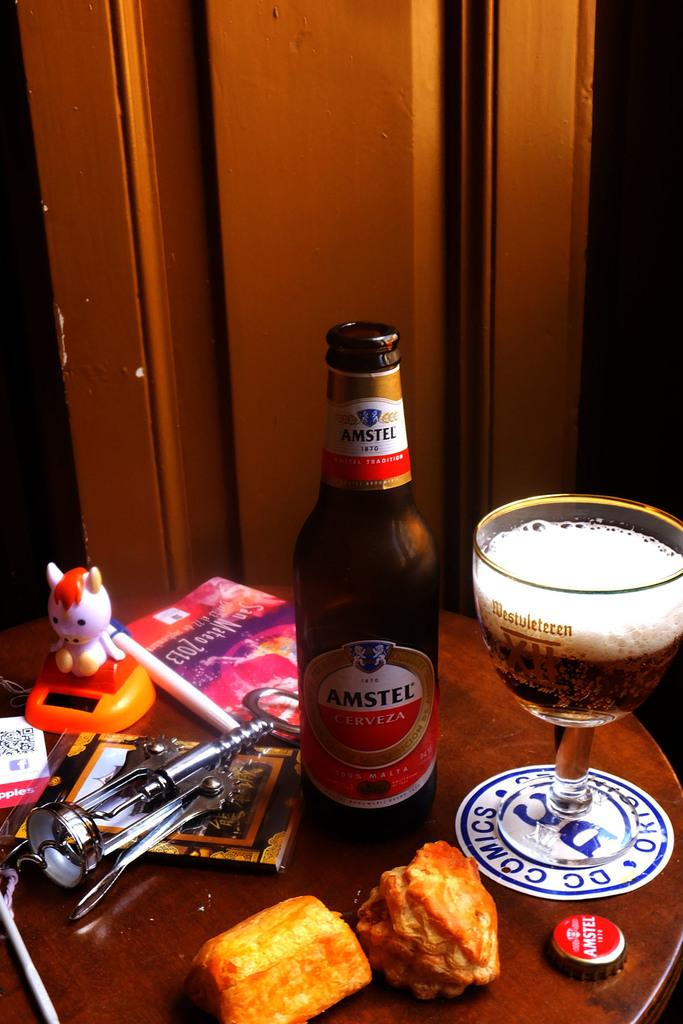<image>
Share a concise interpretation of the image provided. A glass of beer sits on a coaster that says DC Comics. 